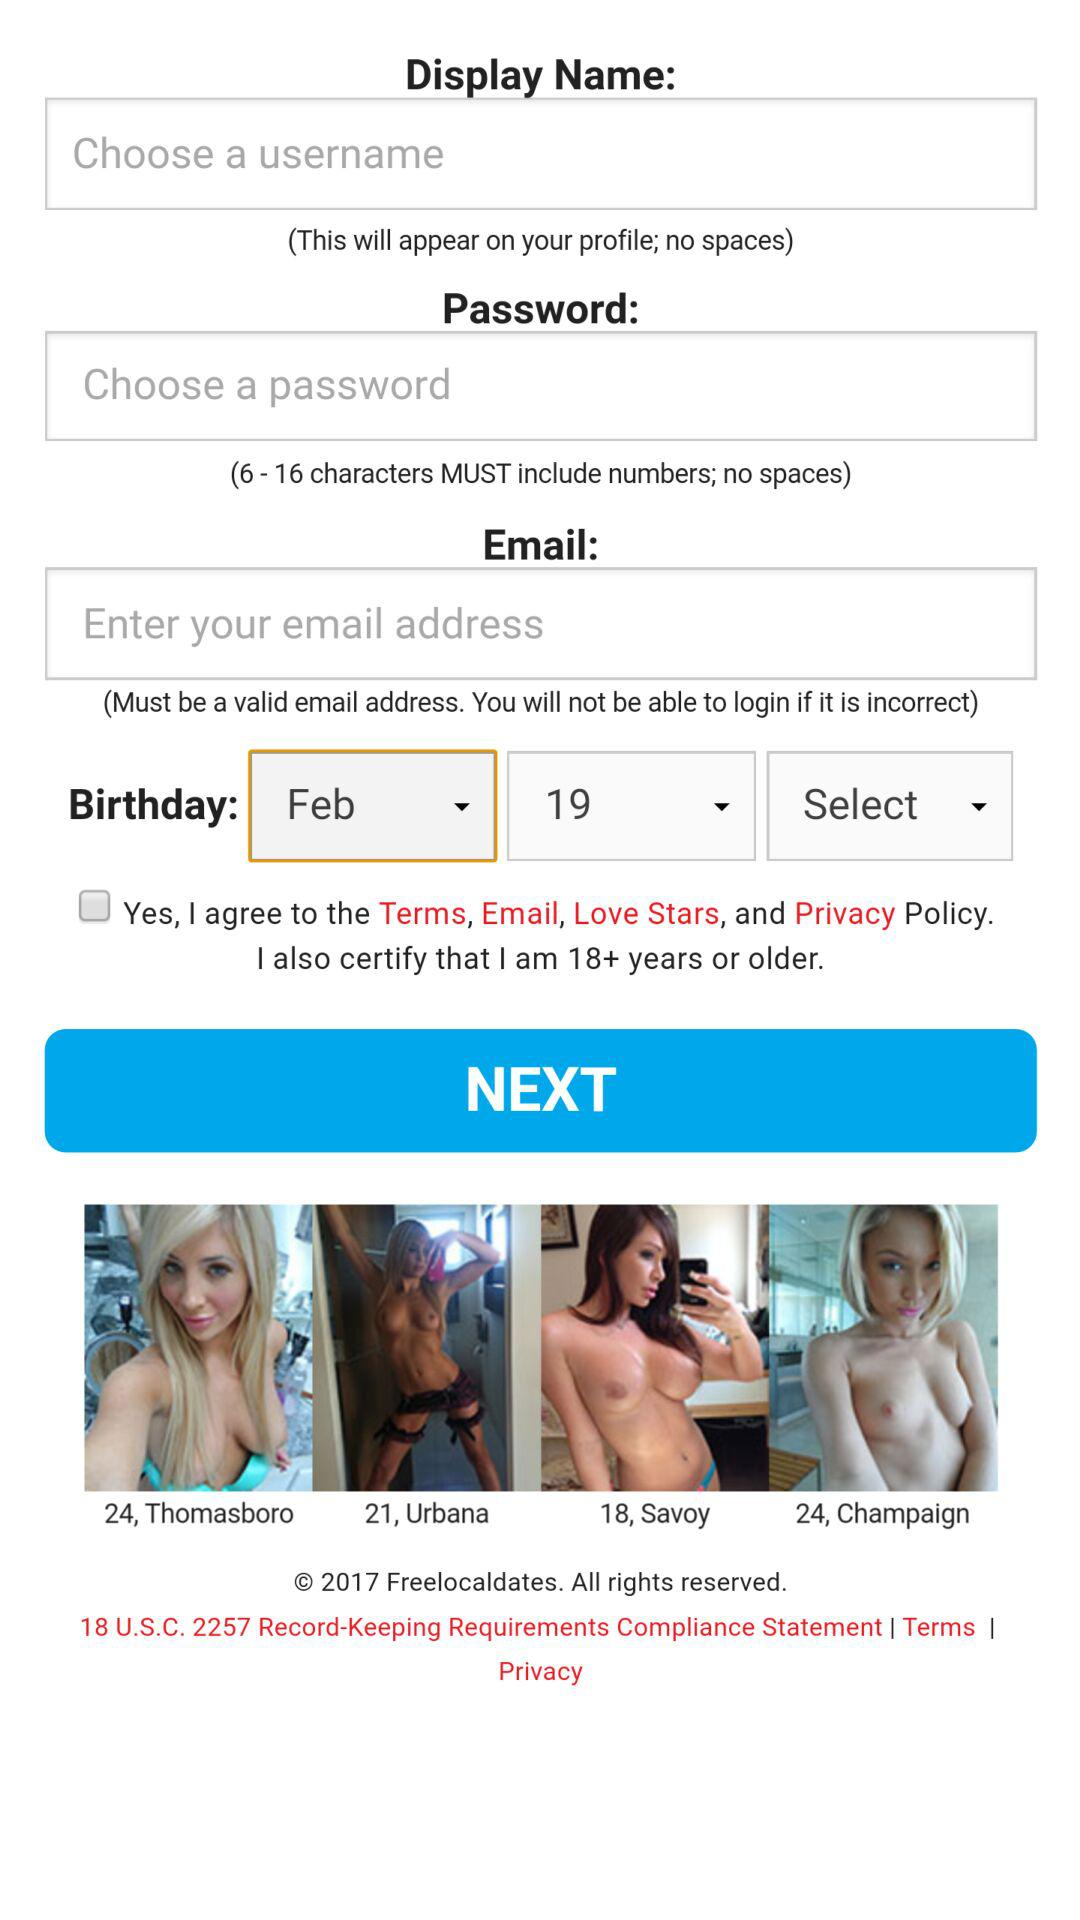What is the minimum age limit to use the application? The minimum age to use the application is 18. 